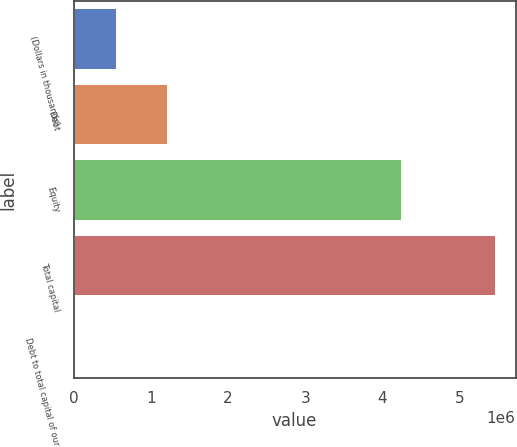Convert chart. <chart><loc_0><loc_0><loc_500><loc_500><bar_chart><fcel>(Dollars in thousands)<fcel>Debt<fcel>Equity<fcel>Total capital<fcel>Debt to total capital of our<nl><fcel>545074<fcel>1.21227e+06<fcel>4.23826e+06<fcel>5.45054e+06<fcel>22.2<nl></chart> 